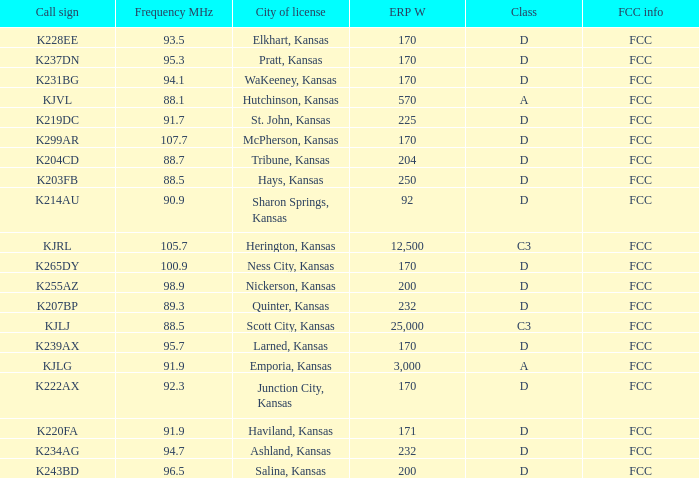Class of d, and a Frequency MHz smaller than 107.7, and a ERP W smaller than 232 has what call sign? K255AZ, K228EE, K220FA, K265DY, K237DN, K214AU, K222AX, K239AX, K243BD, K219DC, K204CD, K231BG. 